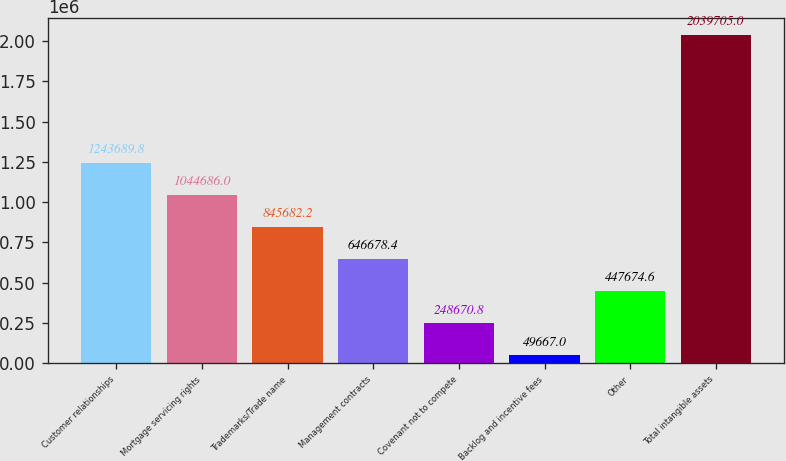Convert chart to OTSL. <chart><loc_0><loc_0><loc_500><loc_500><bar_chart><fcel>Customer relationships<fcel>Mortgage servicing rights<fcel>Trademarks/Trade name<fcel>Management contracts<fcel>Covenant not to compete<fcel>Backlog and incentive fees<fcel>Other<fcel>Total intangible assets<nl><fcel>1.24369e+06<fcel>1.04469e+06<fcel>845682<fcel>646678<fcel>248671<fcel>49667<fcel>447675<fcel>2.0397e+06<nl></chart> 